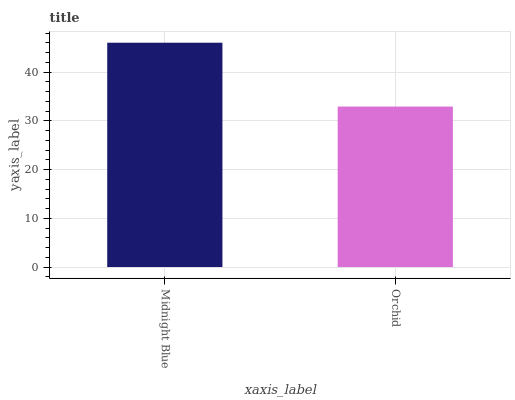Is Orchid the minimum?
Answer yes or no. Yes. Is Midnight Blue the maximum?
Answer yes or no. Yes. Is Orchid the maximum?
Answer yes or no. No. Is Midnight Blue greater than Orchid?
Answer yes or no. Yes. Is Orchid less than Midnight Blue?
Answer yes or no. Yes. Is Orchid greater than Midnight Blue?
Answer yes or no. No. Is Midnight Blue less than Orchid?
Answer yes or no. No. Is Midnight Blue the high median?
Answer yes or no. Yes. Is Orchid the low median?
Answer yes or no. Yes. Is Orchid the high median?
Answer yes or no. No. Is Midnight Blue the low median?
Answer yes or no. No. 